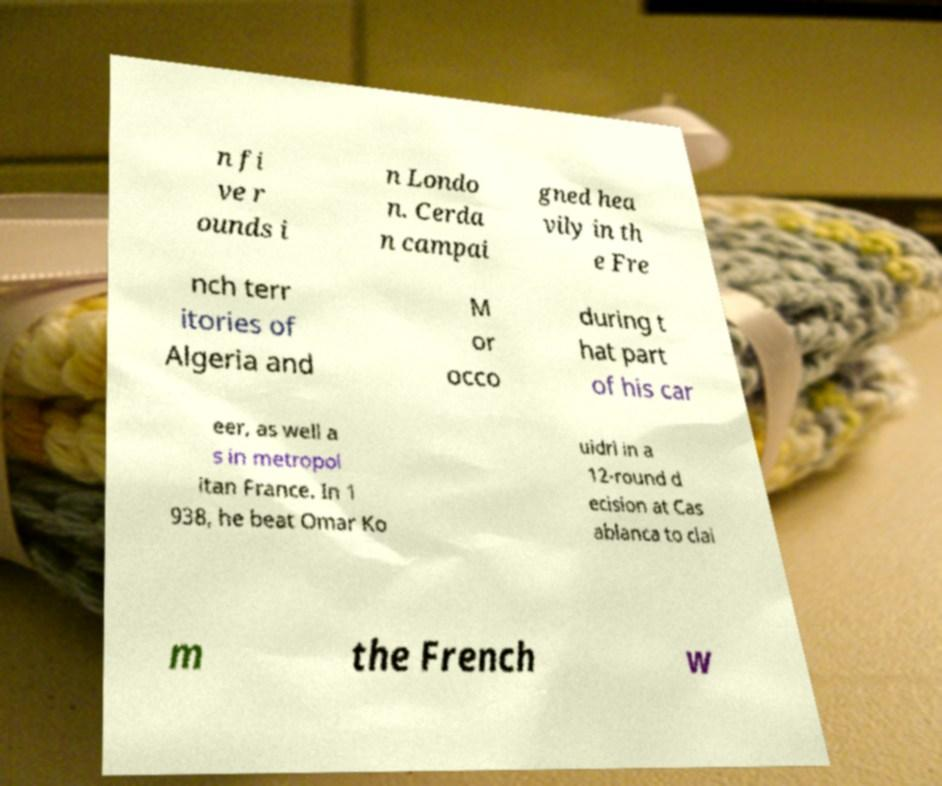Could you extract and type out the text from this image? n fi ve r ounds i n Londo n. Cerda n campai gned hea vily in th e Fre nch terr itories of Algeria and M or occo during t hat part of his car eer, as well a s in metropol itan France. In 1 938, he beat Omar Ko uidri in a 12-round d ecision at Cas ablanca to clai m the French w 